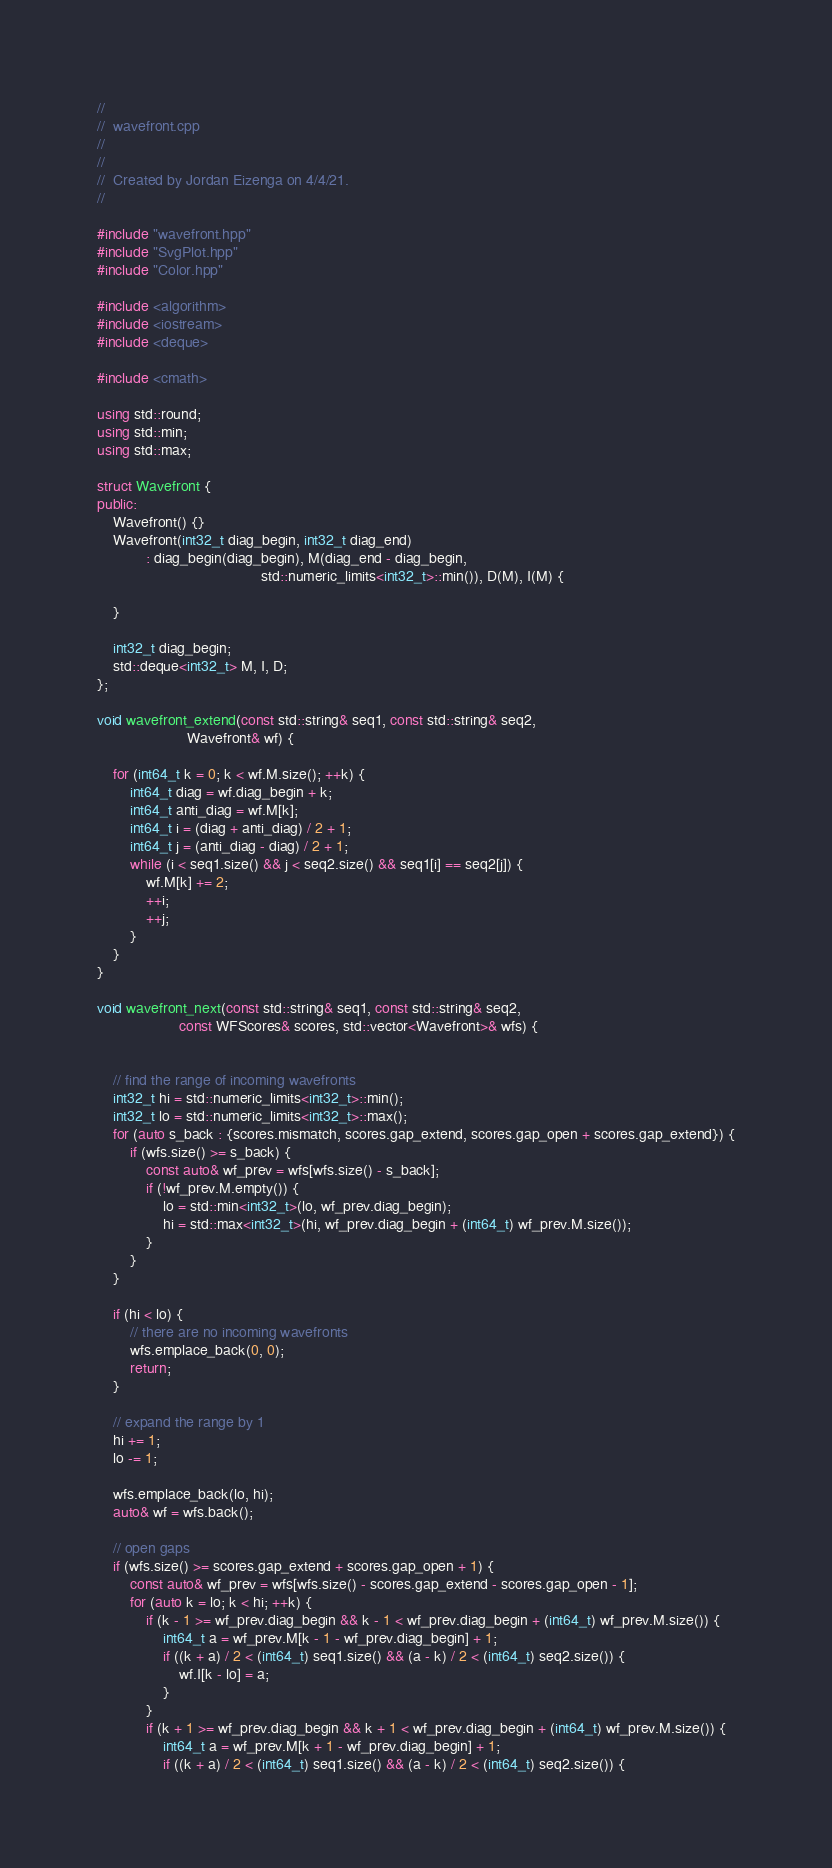Convert code to text. <code><loc_0><loc_0><loc_500><loc_500><_C++_>//
//  wavefront.cpp
//  
//
//  Created by Jordan Eizenga on 4/4/21.
//

#include "wavefront.hpp"
#include "SvgPlot.hpp"
#include "Color.hpp"

#include <algorithm>
#include <iostream>
#include <deque>

#include <cmath>

using std::round;
using std::min;
using std::max;

struct Wavefront {
public:
    Wavefront() {}
    Wavefront(int32_t diag_begin, int32_t diag_end)
            : diag_begin(diag_begin), M(diag_end - diag_begin,
                                        std::numeric_limits<int32_t>::min()), D(M), I(M) {

    }

    int32_t diag_begin;
    std::deque<int32_t> M, I, D;
};

void wavefront_extend(const std::string& seq1, const std::string& seq2,
                      Wavefront& wf) {

    for (int64_t k = 0; k < wf.M.size(); ++k) {
        int64_t diag = wf.diag_begin + k;
        int64_t anti_diag = wf.M[k];
        int64_t i = (diag + anti_diag) / 2 + 1;
        int64_t j = (anti_diag - diag) / 2 + 1;
        while (i < seq1.size() && j < seq2.size() && seq1[i] == seq2[j]) {
            wf.M[k] += 2;
            ++i;
            ++j;
        }
    }
}

void wavefront_next(const std::string& seq1, const std::string& seq2,
                    const WFScores& scores, std::vector<Wavefront>& wfs) {


    // find the range of incoming wavefronts
    int32_t hi = std::numeric_limits<int32_t>::min();
    int32_t lo = std::numeric_limits<int32_t>::max();
    for (auto s_back : {scores.mismatch, scores.gap_extend, scores.gap_open + scores.gap_extend}) {
        if (wfs.size() >= s_back) {
            const auto& wf_prev = wfs[wfs.size() - s_back];
            if (!wf_prev.M.empty()) {
                lo = std::min<int32_t>(lo, wf_prev.diag_begin);
                hi = std::max<int32_t>(hi, wf_prev.diag_begin + (int64_t) wf_prev.M.size());
            }
        }
    }

    if (hi < lo) {
        // there are no incoming wavefronts
        wfs.emplace_back(0, 0);
        return;
    }

    // expand the range by 1
    hi += 1;
    lo -= 1;

    wfs.emplace_back(lo, hi);
    auto& wf = wfs.back();

    // open gaps
    if (wfs.size() >= scores.gap_extend + scores.gap_open + 1) {
        const auto& wf_prev = wfs[wfs.size() - scores.gap_extend - scores.gap_open - 1];
        for (auto k = lo; k < hi; ++k) {
            if (k - 1 >= wf_prev.diag_begin && k - 1 < wf_prev.diag_begin + (int64_t) wf_prev.M.size()) {
                int64_t a = wf_prev.M[k - 1 - wf_prev.diag_begin] + 1;
                if ((k + a) / 2 < (int64_t) seq1.size() && (a - k) / 2 < (int64_t) seq2.size()) {
                    wf.I[k - lo] = a;
                }
            }
            if (k + 1 >= wf_prev.diag_begin && k + 1 < wf_prev.diag_begin + (int64_t) wf_prev.M.size()) {
                int64_t a = wf_prev.M[k + 1 - wf_prev.diag_begin] + 1;
                if ((k + a) / 2 < (int64_t) seq1.size() && (a - k) / 2 < (int64_t) seq2.size()) {</code> 